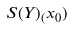Convert formula to latex. <formula><loc_0><loc_0><loc_500><loc_500>S ( Y ) _ { ( } x _ { 0 } )</formula> 